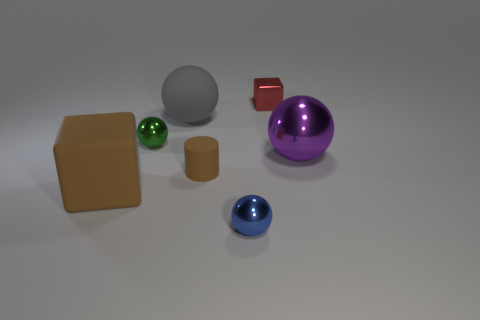Subtract 1 balls. How many balls are left? 3 Subtract all red spheres. Subtract all red cylinders. How many spheres are left? 4 Add 1 tiny green objects. How many objects exist? 8 Subtract all cylinders. How many objects are left? 6 Add 1 big yellow rubber spheres. How many big yellow rubber spheres exist? 1 Subtract 0 gray cylinders. How many objects are left? 7 Subtract all big purple rubber cubes. Subtract all brown things. How many objects are left? 5 Add 5 tiny brown matte objects. How many tiny brown matte objects are left? 6 